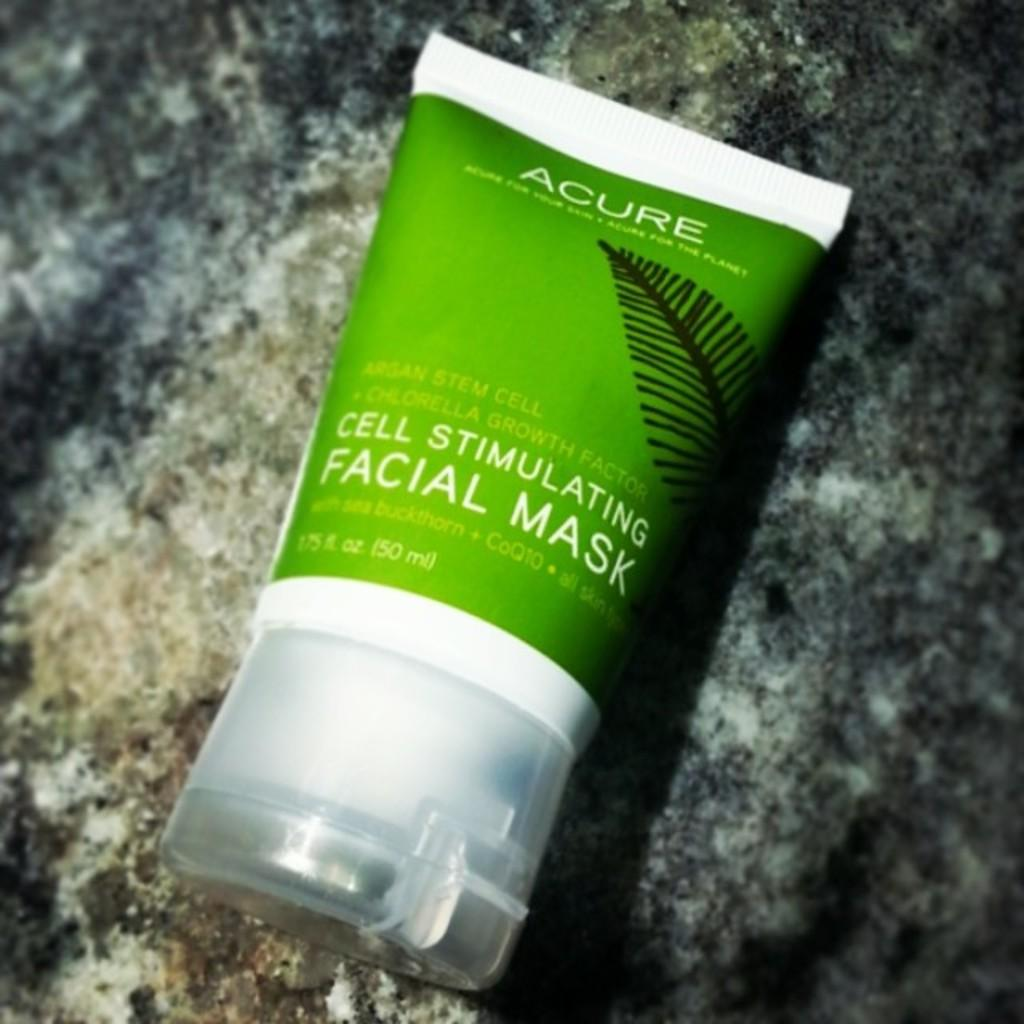<image>
Offer a succinct explanation of the picture presented. The product in the plastic container is a facial mask 